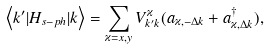<formula> <loc_0><loc_0><loc_500><loc_500>\left \langle k ^ { \prime } | H _ { s - p h } | k \right \rangle = \sum _ { \varkappa = x , y } V _ { k ^ { \prime } k } ^ { \varkappa } ( a _ { \varkappa , - \Delta k } + a _ { \varkappa , \Delta k } ^ { \dagger } ) ,</formula> 